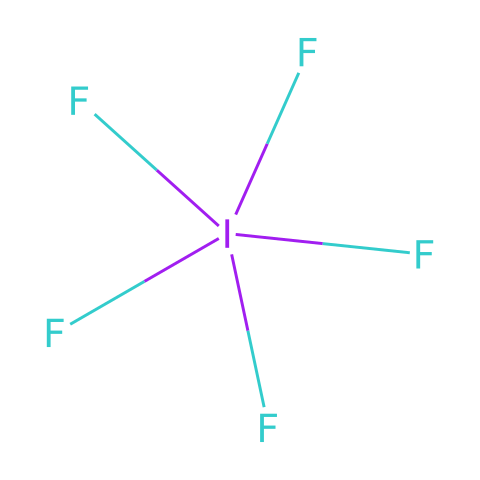What is the chemical name of this compound? The structure shows an iodine atom surrounded by five fluorine atoms. The name for this compound with one iodine and five fluorine is known as iodine pentafluoride.
Answer: iodine pentafluoride How many fluorine atoms are present in this compound? Observing the SMILES representation, there are five fluorine atoms bonded to the iodine atom, which we can count directly from the structure.
Answer: five Is this compound a hypervalent compound? Since iodine has more than eight valence electrons in this structure (it is surrounded by five fluorine atoms), it qualifies as a hypervalent compound.
Answer: yes What is the oxidation state of iodine in iodine pentafluoride? In this compound, the oxidation state of iodine can be determined by considering that fluorine typically has an oxidation state of -1. With five fluorine atoms, iodine would have an oxidation state of +5.
Answer: +5 What type of bonding is present in iodine pentafluoride? The bonding can be analyzed by looking at the connections between the iodine and the fluorine atoms. Since all fluorine atoms are present as single bonds with iodine, it is classified as covalent bonding.
Answer: covalent What is the primary property that makes iodine pentafluoride a powerful oxidizing agent? The significant electronegativity difference between the iodine and fluorine leads to a strong oxidizing behavior, as the compound can readily accept electrons.
Answer: high electronegativity 